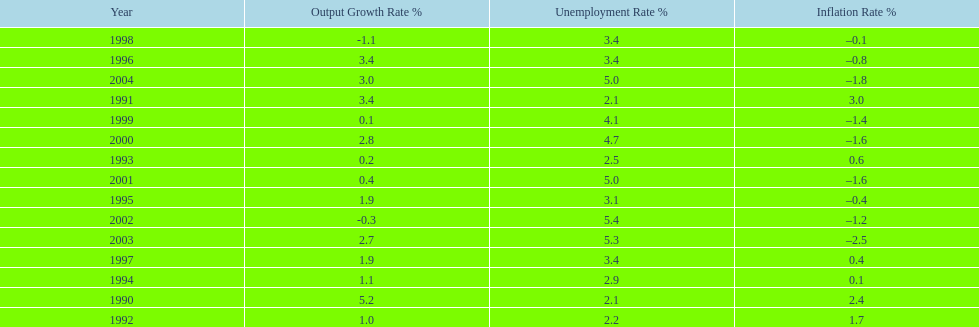What year saw the highest output growth rate in japan between the years 1990 and 2004? 1990. 